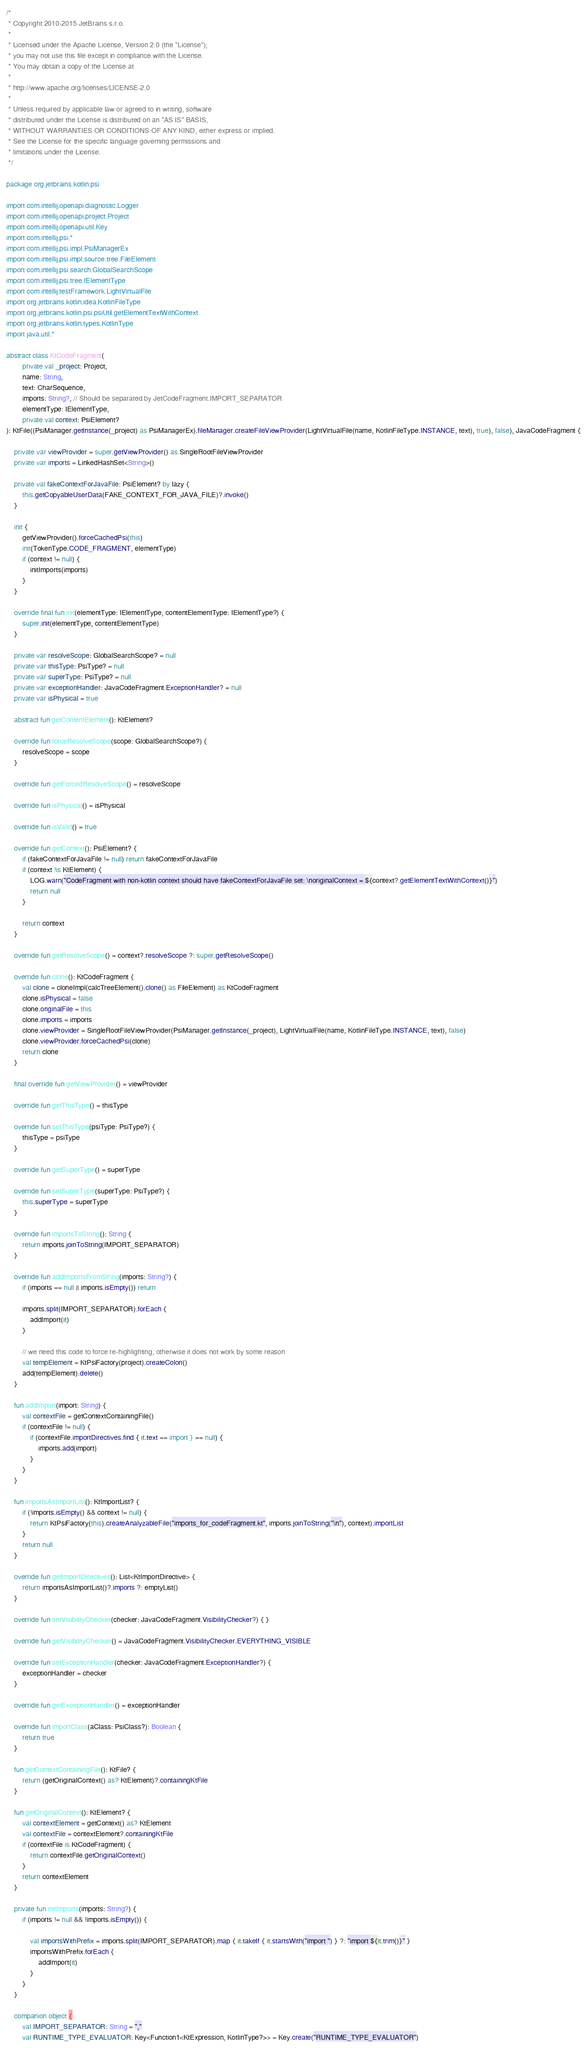Convert code to text. <code><loc_0><loc_0><loc_500><loc_500><_Kotlin_>/*
 * Copyright 2010-2015 JetBrains s.r.o.
 *
 * Licensed under the Apache License, Version 2.0 (the "License");
 * you may not use this file except in compliance with the License.
 * You may obtain a copy of the License at
 *
 * http://www.apache.org/licenses/LICENSE-2.0
 *
 * Unless required by applicable law or agreed to in writing, software
 * distributed under the License is distributed on an "AS IS" BASIS,
 * WITHOUT WARRANTIES OR CONDITIONS OF ANY KIND, either express or implied.
 * See the License for the specific language governing permissions and
 * limitations under the License.
 */

package org.jetbrains.kotlin.psi

import com.intellij.openapi.diagnostic.Logger
import com.intellij.openapi.project.Project
import com.intellij.openapi.util.Key
import com.intellij.psi.*
import com.intellij.psi.impl.PsiManagerEx
import com.intellij.psi.impl.source.tree.FileElement
import com.intellij.psi.search.GlobalSearchScope
import com.intellij.psi.tree.IElementType
import com.intellij.testFramework.LightVirtualFile
import org.jetbrains.kotlin.idea.KotlinFileType
import org.jetbrains.kotlin.psi.psiUtil.getElementTextWithContext
import org.jetbrains.kotlin.types.KotlinType
import java.util.*

abstract class KtCodeFragment(
        private val _project: Project,
        name: String,
        text: CharSequence,
        imports: String?, // Should be separated by JetCodeFragment.IMPORT_SEPARATOR
        elementType: IElementType,
        private val context: PsiElement?
): KtFile((PsiManager.getInstance(_project) as PsiManagerEx).fileManager.createFileViewProvider(LightVirtualFile(name, KotlinFileType.INSTANCE, text), true), false), JavaCodeFragment {

    private var viewProvider = super.getViewProvider() as SingleRootFileViewProvider
    private var imports = LinkedHashSet<String>()

    private val fakeContextForJavaFile: PsiElement? by lazy {
        this.getCopyableUserData(FAKE_CONTEXT_FOR_JAVA_FILE)?.invoke()
    }

    init {
        getViewProvider().forceCachedPsi(this)
        init(TokenType.CODE_FRAGMENT, elementType)
        if (context != null) {
            initImports(imports)
        }
    }

    override final fun init(elementType: IElementType, contentElementType: IElementType?) {
        super.init(elementType, contentElementType)
    }

    private var resolveScope: GlobalSearchScope? = null
    private var thisType: PsiType? = null
    private var superType: PsiType? = null
    private var exceptionHandler: JavaCodeFragment.ExceptionHandler? = null
    private var isPhysical = true

    abstract fun getContentElement(): KtElement?

    override fun forceResolveScope(scope: GlobalSearchScope?) {
        resolveScope = scope
    }

    override fun getForcedResolveScope() = resolveScope

    override fun isPhysical() = isPhysical

    override fun isValid() = true

    override fun getContext(): PsiElement? {
        if (fakeContextForJavaFile != null) return fakeContextForJavaFile
        if (context !is KtElement) {
            LOG.warn("CodeFragment with non-kotlin context should have fakeContextForJavaFile set: \noriginalContext = ${context?.getElementTextWithContext()}")
            return null
        }

        return context
    }

    override fun getResolveScope() = context?.resolveScope ?: super.getResolveScope()

    override fun clone(): KtCodeFragment {
        val clone = cloneImpl(calcTreeElement().clone() as FileElement) as KtCodeFragment
        clone.isPhysical = false
        clone.originalFile = this
        clone.imports = imports
        clone.viewProvider = SingleRootFileViewProvider(PsiManager.getInstance(_project), LightVirtualFile(name, KotlinFileType.INSTANCE, text), false)
        clone.viewProvider.forceCachedPsi(clone)
        return clone
    }

    final override fun getViewProvider() = viewProvider

    override fun getThisType() = thisType

    override fun setThisType(psiType: PsiType?) {
        thisType = psiType
    }

    override fun getSuperType() = superType

    override fun setSuperType(superType: PsiType?) {
        this.superType = superType
    }

    override fun importsToString(): String {
        return imports.joinToString(IMPORT_SEPARATOR)
    }

    override fun addImportsFromString(imports: String?) {
        if (imports == null || imports.isEmpty()) return

        imports.split(IMPORT_SEPARATOR).forEach {
            addImport(it)
        }

        // we need this code to force re-highlighting, otherwise it does not work by some reason
        val tempElement = KtPsiFactory(project).createColon()
        add(tempElement).delete()
    }

    fun addImport(import: String) {
        val contextFile = getContextContainingFile()
        if (contextFile != null) {
            if (contextFile.importDirectives.find { it.text == import } == null) {
                imports.add(import)
            }
        }
    }

    fun importsAsImportList(): KtImportList? {
        if (!imports.isEmpty() && context != null) {
            return KtPsiFactory(this).createAnalyzableFile("imports_for_codeFragment.kt", imports.joinToString("\n"), context).importList
        }
        return null
    }

    override fun getImportDirectives(): List<KtImportDirective> {
        return importsAsImportList()?.imports ?: emptyList()
    }

    override fun setVisibilityChecker(checker: JavaCodeFragment.VisibilityChecker?) { }

    override fun getVisibilityChecker() = JavaCodeFragment.VisibilityChecker.EVERYTHING_VISIBLE

    override fun setExceptionHandler(checker: JavaCodeFragment.ExceptionHandler?) {
        exceptionHandler = checker
    }

    override fun getExceptionHandler() = exceptionHandler

    override fun importClass(aClass: PsiClass?): Boolean {
        return true
    }

    fun getContextContainingFile(): KtFile? {
        return (getOriginalContext() as? KtElement)?.containingKtFile
    }

    fun getOriginalContext(): KtElement? {
        val contextElement = getContext() as? KtElement
        val contextFile = contextElement?.containingKtFile
        if (contextFile is KtCodeFragment) {
            return contextFile.getOriginalContext()
        }
        return contextElement
    }

    private fun initImports(imports: String?) {
        if (imports != null && !imports.isEmpty()) {

            val importsWithPrefix = imports.split(IMPORT_SEPARATOR).map { it.takeIf { it.startsWith("import ") } ?: "import ${it.trim()}" }
            importsWithPrefix.forEach {
                addImport(it)
            }
        }
    }

    companion object {
        val IMPORT_SEPARATOR: String = ","
        val RUNTIME_TYPE_EVALUATOR: Key<Function1<KtExpression, KotlinType?>> = Key.create("RUNTIME_TYPE_EVALUATOR")</code> 